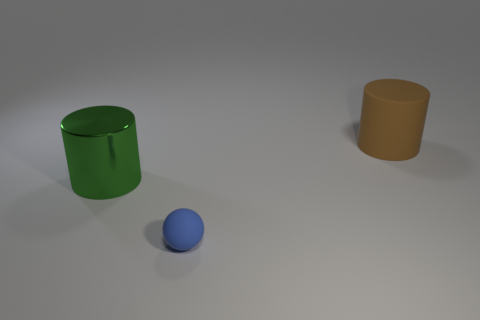Add 3 tiny brown rubber objects. How many objects exist? 6 Subtract all cylinders. How many objects are left? 1 Subtract all green metal cylinders. Subtract all green metal things. How many objects are left? 1 Add 2 big shiny cylinders. How many big shiny cylinders are left? 3 Add 3 yellow metallic things. How many yellow metallic things exist? 3 Subtract 0 cyan cubes. How many objects are left? 3 